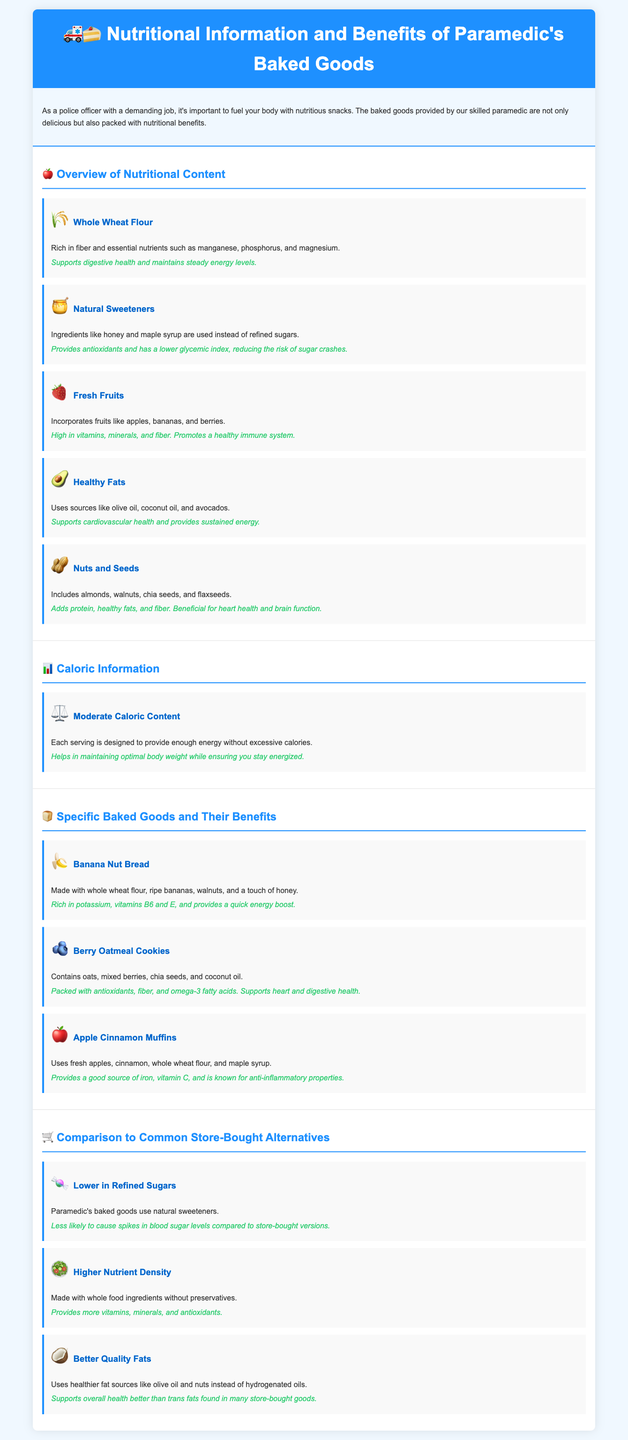What are the main ingredients used for sweetening? The document states that natural sweeteners like honey and maple syrup are used instead of refined sugars.
Answer: Natural sweeteners What type of flour is used in the baked goods? The baked goods are made with whole wheat flour, which is highlighted in the overview section.
Answer: Whole wheat flour What is a key benefit of including fresh fruits? The document mentions that fresh fruits promote a healthy immune system.
Answer: Promotes a healthy immune system How many specific baked goods are mentioned in the document? The document lists three specific baked goods: Banana Nut Bread, Berry Oatmeal Cookies, and Apple Cinnamon Muffins.
Answer: Three What is a nutritional benefit of nuts and seeds? The document states that nuts and seeds are beneficial for heart health and brain function due to their protein, healthy fats, and fiber content.
Answer: Heart health and brain function What is the caloric content design for each serving? The document indicates that each serving is designed to provide enough energy without excessive calories.
Answer: Moderate caloric content Which baked good is rich in potassium? The Banana Nut Bread is specified to be rich in potassium along with vitamins B6 and E.
Answer: Banana Nut Bread What is emphasized as being lower in paramedic's baked goods compared to store-bought alternatives? The document emphasizes that paramedic's baked goods are lower in refined sugars.
Answer: Lower in refined sugars What type of fats does the paramedic use in baking? The document states that healthier fat sources like olive oil and nuts are used instead of hydrogenated oils.
Answer: Healthier fat sources 